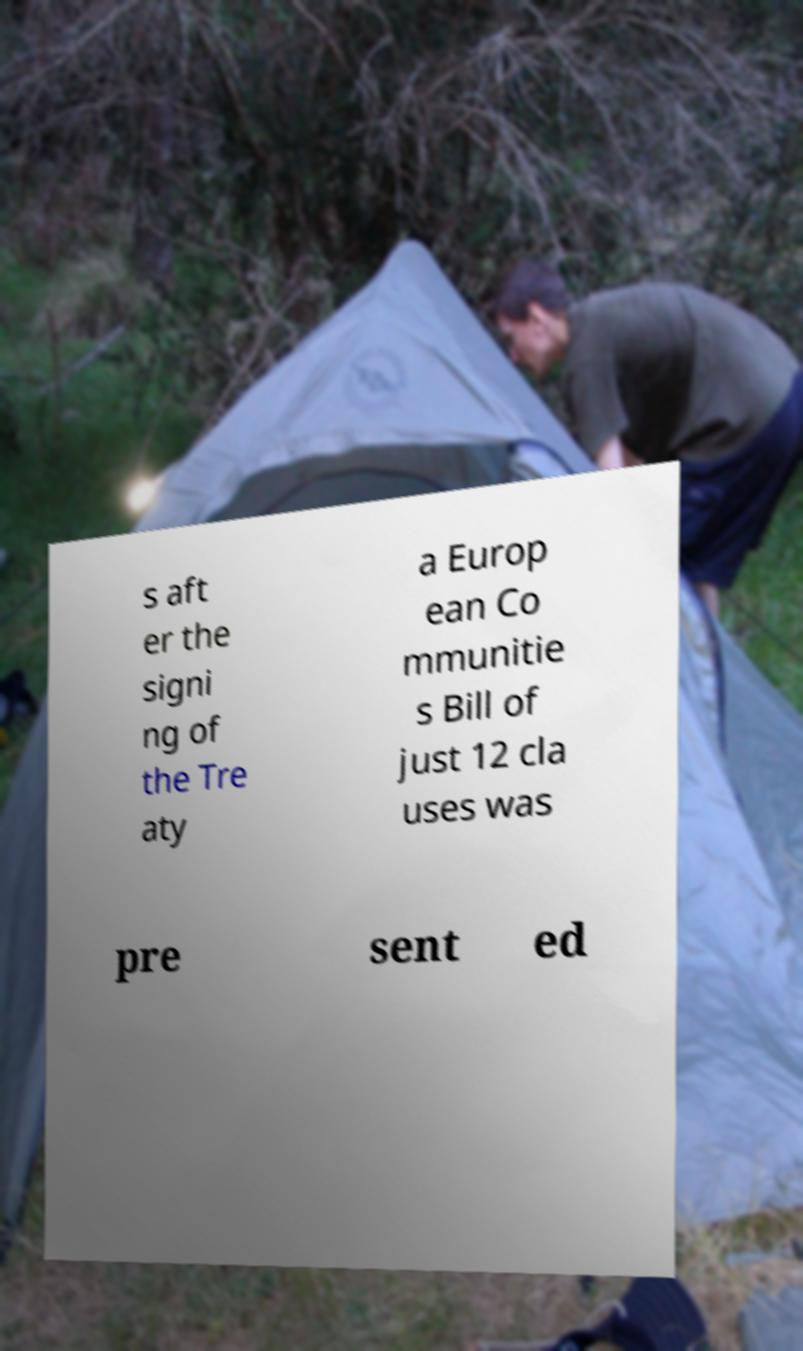There's text embedded in this image that I need extracted. Can you transcribe it verbatim? s aft er the signi ng of the Tre aty a Europ ean Co mmunitie s Bill of just 12 cla uses was pre sent ed 